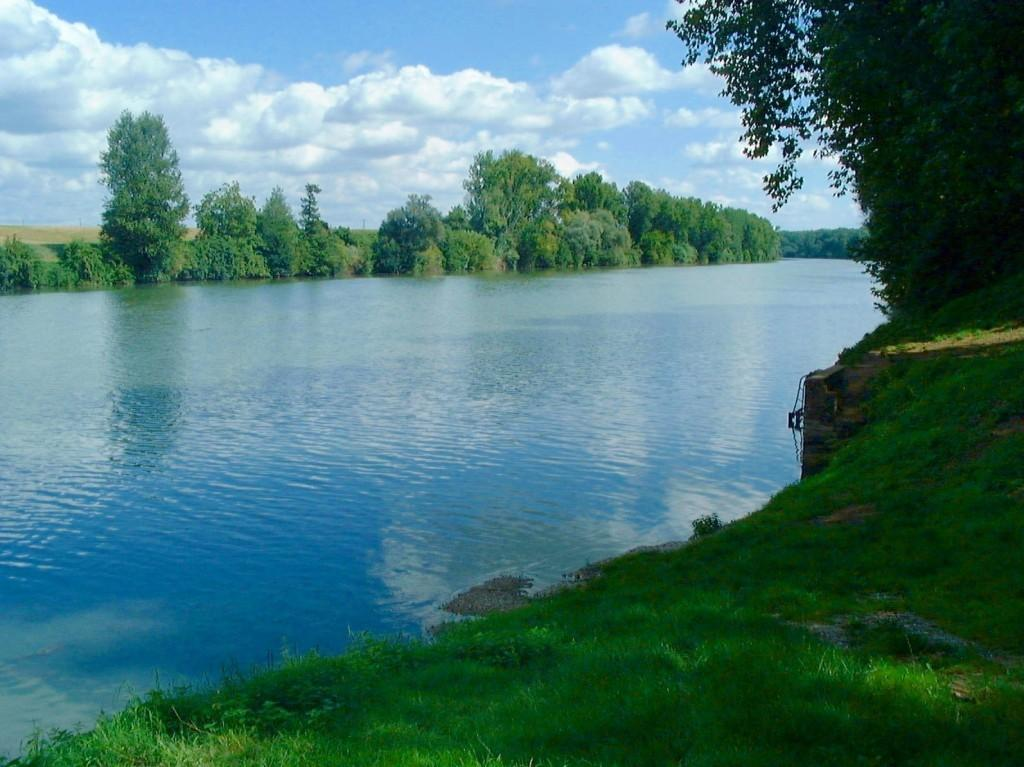What is the main feature in the center of the image? There is a lake in the center of the image. What type of vegetation can be seen in the image? There are trees visible in the image. What is at the bottom of the image? There is grass at the bottom of the image. What can be seen in the background of the image? The sky is visible in the background of the image. What type of trouble can be seen in the image? There is no trouble visible in the image; it features a lake, trees, grass, and the sky. What type of power is being generated in the image? There is no power generation visible in the image; it features a lake, trees, grass, and the sky. 